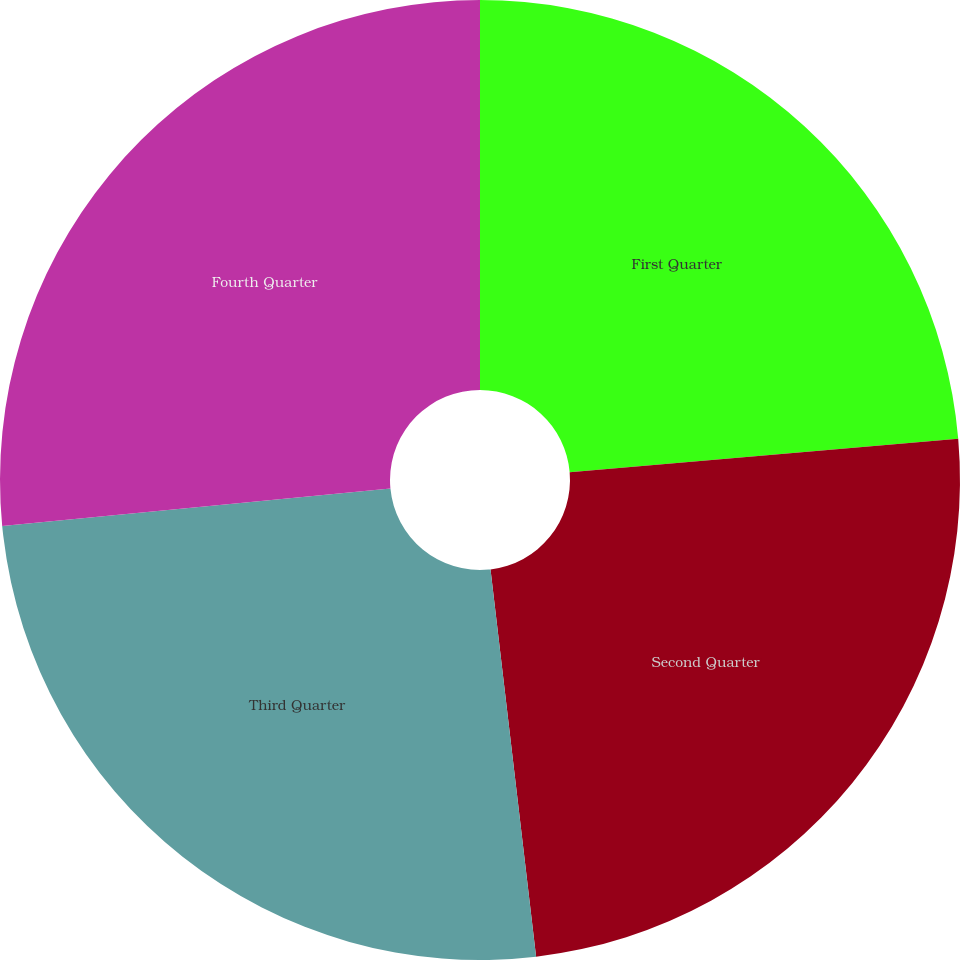Convert chart to OTSL. <chart><loc_0><loc_0><loc_500><loc_500><pie_chart><fcel>First Quarter<fcel>Second Quarter<fcel>Third Quarter<fcel>Fourth Quarter<nl><fcel>23.63%<fcel>24.51%<fcel>25.34%<fcel>26.53%<nl></chart> 